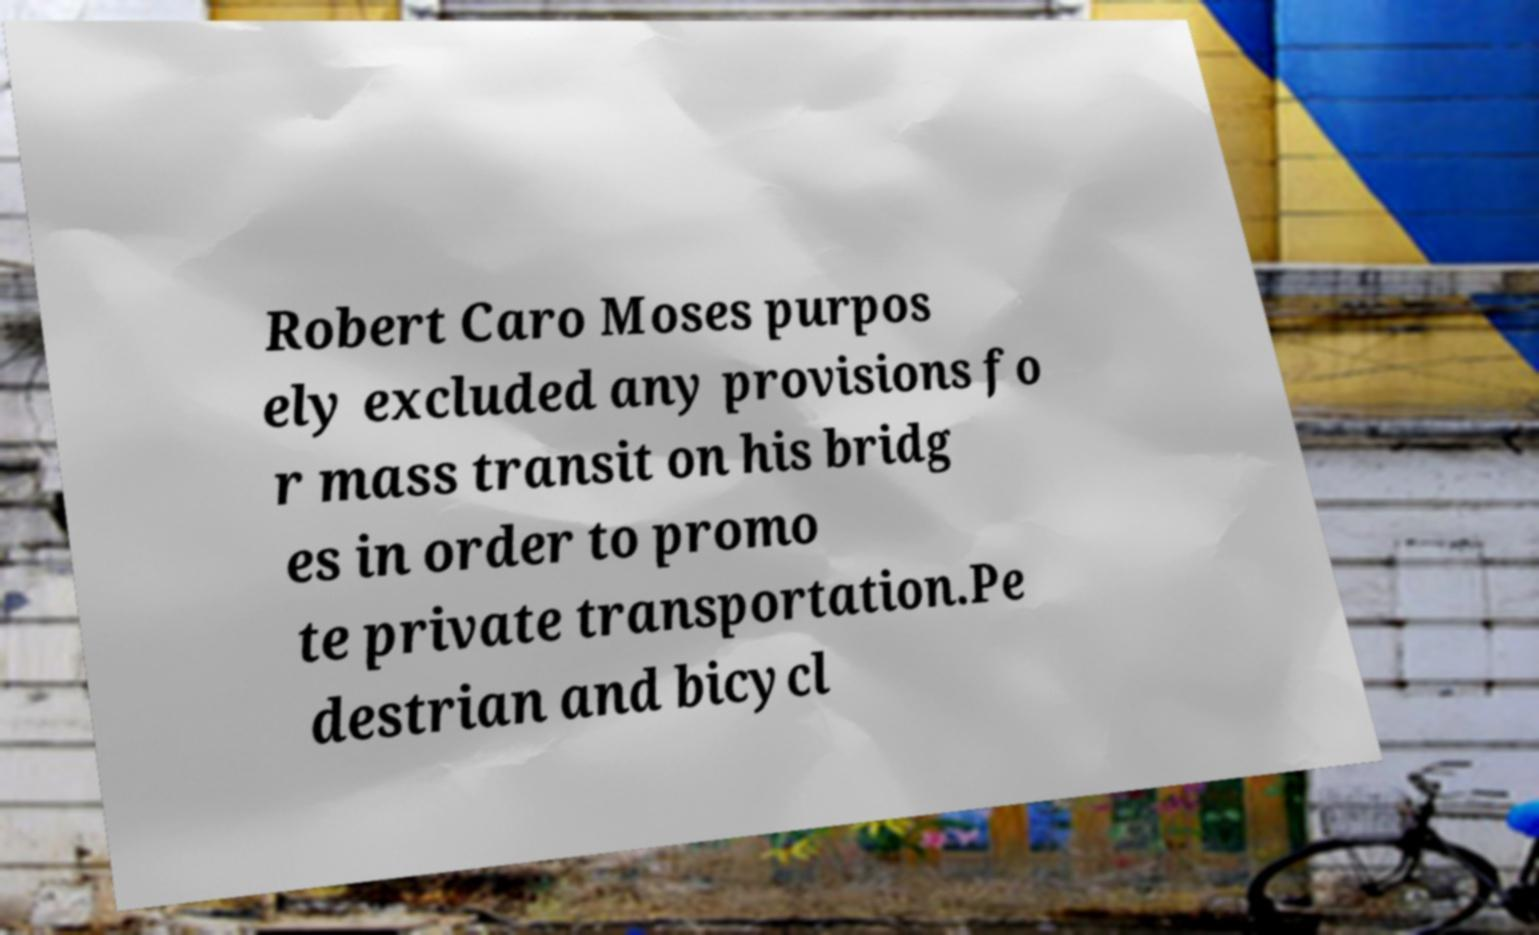I need the written content from this picture converted into text. Can you do that? Robert Caro Moses purpos ely excluded any provisions fo r mass transit on his bridg es in order to promo te private transportation.Pe destrian and bicycl 